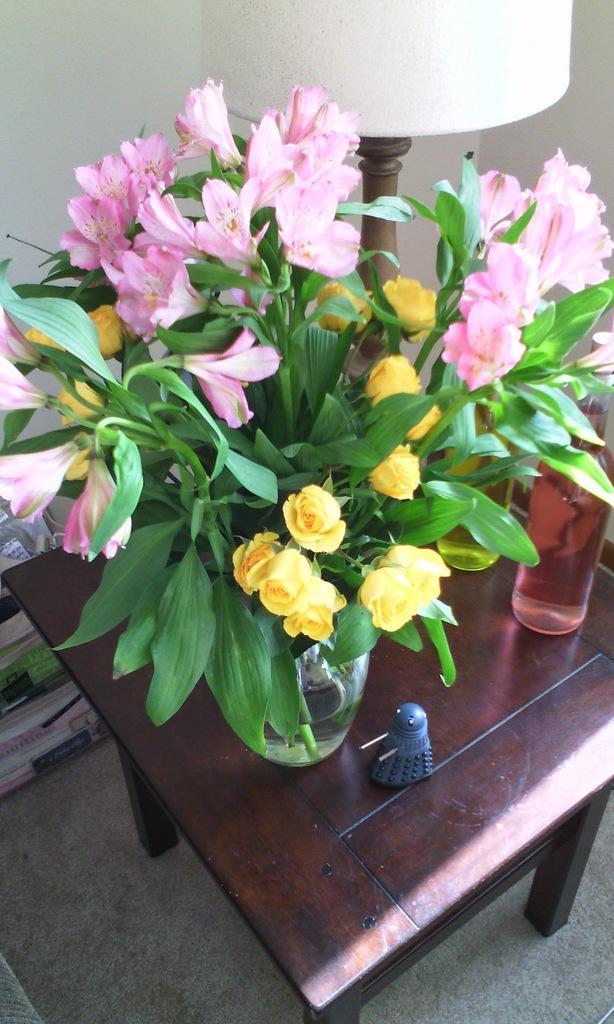Please provide a concise description of this image. In this image I can see a plant and a bottle on this table. I can also see a lamp. 